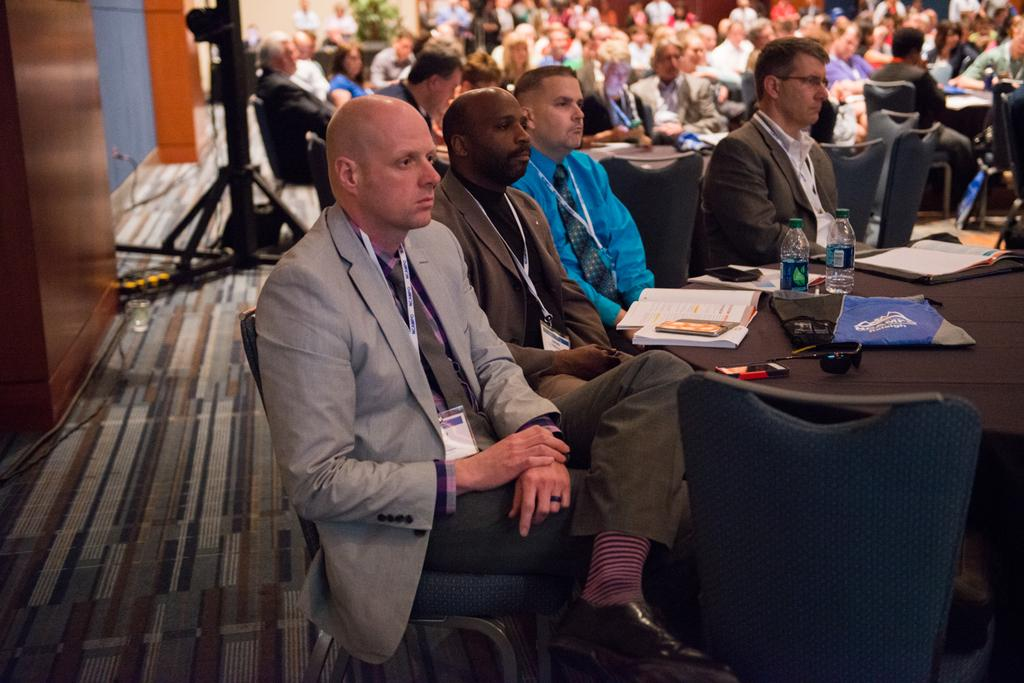How many people are in the image? There is a group of people in the image. What are the people doing in the image? The people are sitting on chairs. What objects can be seen on the tables in the image? There is a book, bottles, a cloth, and a paper on one of the tables. What type of nail is being hammered into the table in the image? There is no nail being hammered into the table in the image. What time of day is it in the image? The time of day is not mentioned in the image, so it cannot be determined. 